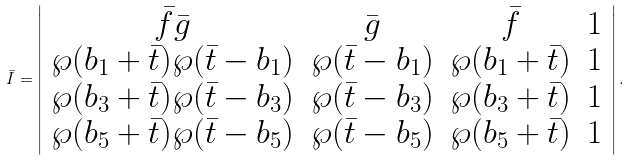Convert formula to latex. <formula><loc_0><loc_0><loc_500><loc_500>\bar { I } = \left | \begin{array} { c c c c } \bar { f } \bar { g } & \bar { g } & \bar { f } & 1 \\ \wp ( b _ { 1 } + \bar { t } ) \wp ( \bar { t } - b _ { 1 } ) & \wp ( \bar { t } - b _ { 1 } ) & \wp ( b _ { 1 } + \bar { t } ) & 1 \\ \wp ( b _ { 3 } + \bar { t } ) \wp ( \bar { t } - b _ { 3 } ) & \wp ( \bar { t } - b _ { 3 } ) & \wp ( b _ { 3 } + \bar { t } ) & 1 \\ \wp ( b _ { 5 } + \bar { t } ) \wp ( \bar { t } - b _ { 5 } ) & \wp ( \bar { t } - b _ { 5 } ) & \wp ( b _ { 5 } + \bar { t } ) & 1 \end{array} \right | .</formula> 